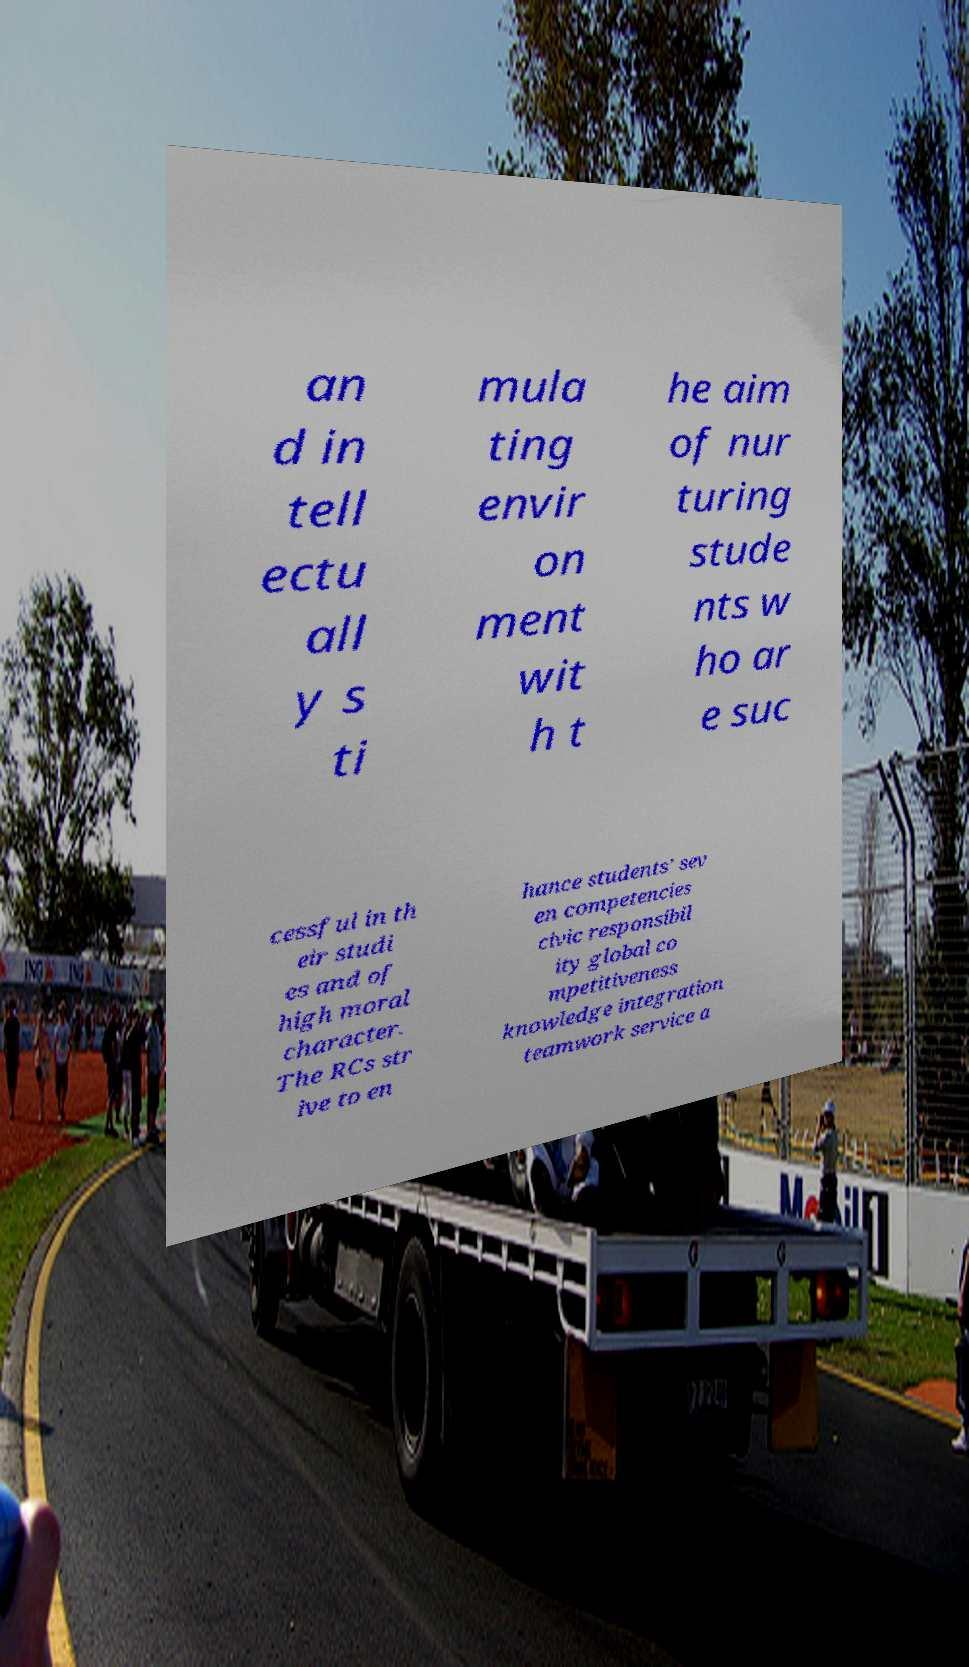There's text embedded in this image that I need extracted. Can you transcribe it verbatim? an d in tell ectu all y s ti mula ting envir on ment wit h t he aim of nur turing stude nts w ho ar e suc cessful in th eir studi es and of high moral character. The RCs str ive to en hance students’ sev en competencies civic responsibil ity global co mpetitiveness knowledge integration teamwork service a 